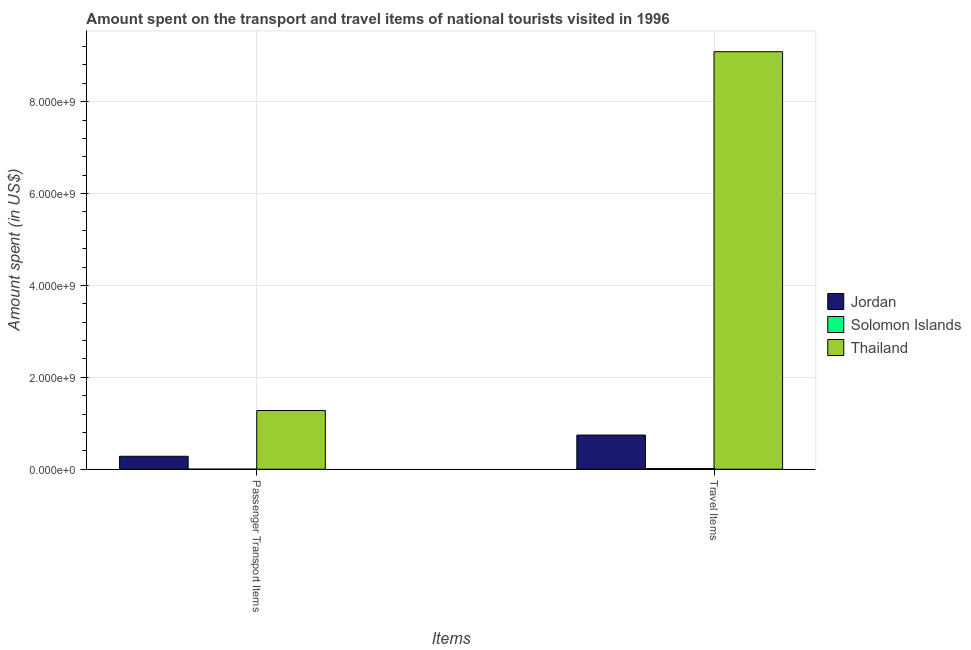How many groups of bars are there?
Your answer should be very brief. 2. Are the number of bars on each tick of the X-axis equal?
Offer a terse response. Yes. What is the label of the 2nd group of bars from the left?
Provide a short and direct response. Travel Items. What is the amount spent in travel items in Solomon Islands?
Your answer should be very brief. 1.39e+07. Across all countries, what is the maximum amount spent on passenger transport items?
Your response must be concise. 1.28e+09. Across all countries, what is the minimum amount spent in travel items?
Offer a terse response. 1.39e+07. In which country was the amount spent in travel items maximum?
Make the answer very short. Thailand. In which country was the amount spent on passenger transport items minimum?
Your answer should be compact. Solomon Islands. What is the total amount spent in travel items in the graph?
Offer a terse response. 9.85e+09. What is the difference between the amount spent on passenger transport items in Thailand and that in Solomon Islands?
Provide a short and direct response. 1.28e+09. What is the difference between the amount spent on passenger transport items in Jordan and the amount spent in travel items in Solomon Islands?
Your answer should be very brief. 2.68e+08. What is the average amount spent in travel items per country?
Provide a short and direct response. 3.28e+09. What is the difference between the amount spent on passenger transport items and amount spent in travel items in Thailand?
Your answer should be compact. -7.81e+09. In how many countries, is the amount spent in travel items greater than 1600000000 US$?
Offer a very short reply. 1. What is the ratio of the amount spent on passenger transport items in Solomon Islands to that in Thailand?
Offer a terse response. 0. Is the amount spent in travel items in Solomon Islands less than that in Thailand?
Offer a very short reply. Yes. In how many countries, is the amount spent in travel items greater than the average amount spent in travel items taken over all countries?
Provide a succinct answer. 1. What does the 1st bar from the left in Passenger Transport Items represents?
Provide a succinct answer. Jordan. What does the 2nd bar from the right in Travel Items represents?
Offer a very short reply. Solomon Islands. Are all the bars in the graph horizontal?
Ensure brevity in your answer.  No. How many countries are there in the graph?
Offer a terse response. 3. What is the difference between two consecutive major ticks on the Y-axis?
Provide a short and direct response. 2.00e+09. Are the values on the major ticks of Y-axis written in scientific E-notation?
Your response must be concise. Yes. Does the graph contain grids?
Ensure brevity in your answer.  Yes. How many legend labels are there?
Your answer should be compact. 3. What is the title of the graph?
Offer a very short reply. Amount spent on the transport and travel items of national tourists visited in 1996. Does "Middle income" appear as one of the legend labels in the graph?
Offer a terse response. No. What is the label or title of the X-axis?
Offer a very short reply. Items. What is the label or title of the Y-axis?
Provide a short and direct response. Amount spent (in US$). What is the Amount spent (in US$) in Jordan in Passenger Transport Items?
Provide a short and direct response. 2.82e+08. What is the Amount spent (in US$) in Solomon Islands in Passenger Transport Items?
Offer a terse response. 2.10e+06. What is the Amount spent (in US$) of Thailand in Passenger Transport Items?
Your response must be concise. 1.28e+09. What is the Amount spent (in US$) of Jordan in Travel Items?
Provide a succinct answer. 7.44e+08. What is the Amount spent (in US$) of Solomon Islands in Travel Items?
Provide a short and direct response. 1.39e+07. What is the Amount spent (in US$) of Thailand in Travel Items?
Provide a succinct answer. 9.09e+09. Across all Items, what is the maximum Amount spent (in US$) in Jordan?
Ensure brevity in your answer.  7.44e+08. Across all Items, what is the maximum Amount spent (in US$) in Solomon Islands?
Keep it short and to the point. 1.39e+07. Across all Items, what is the maximum Amount spent (in US$) of Thailand?
Keep it short and to the point. 9.09e+09. Across all Items, what is the minimum Amount spent (in US$) of Jordan?
Your answer should be compact. 2.82e+08. Across all Items, what is the minimum Amount spent (in US$) in Solomon Islands?
Give a very brief answer. 2.10e+06. Across all Items, what is the minimum Amount spent (in US$) in Thailand?
Provide a succinct answer. 1.28e+09. What is the total Amount spent (in US$) of Jordan in the graph?
Offer a terse response. 1.03e+09. What is the total Amount spent (in US$) in Solomon Islands in the graph?
Give a very brief answer. 1.60e+07. What is the total Amount spent (in US$) of Thailand in the graph?
Keep it short and to the point. 1.04e+1. What is the difference between the Amount spent (in US$) of Jordan in Passenger Transport Items and that in Travel Items?
Keep it short and to the point. -4.62e+08. What is the difference between the Amount spent (in US$) in Solomon Islands in Passenger Transport Items and that in Travel Items?
Provide a succinct answer. -1.18e+07. What is the difference between the Amount spent (in US$) in Thailand in Passenger Transport Items and that in Travel Items?
Offer a very short reply. -7.81e+09. What is the difference between the Amount spent (in US$) in Jordan in Passenger Transport Items and the Amount spent (in US$) in Solomon Islands in Travel Items?
Your answer should be very brief. 2.68e+08. What is the difference between the Amount spent (in US$) of Jordan in Passenger Transport Items and the Amount spent (in US$) of Thailand in Travel Items?
Make the answer very short. -8.81e+09. What is the difference between the Amount spent (in US$) of Solomon Islands in Passenger Transport Items and the Amount spent (in US$) of Thailand in Travel Items?
Your answer should be very brief. -9.09e+09. What is the average Amount spent (in US$) in Jordan per Items?
Provide a succinct answer. 5.13e+08. What is the average Amount spent (in US$) of Solomon Islands per Items?
Ensure brevity in your answer.  8.00e+06. What is the average Amount spent (in US$) of Thailand per Items?
Give a very brief answer. 5.18e+09. What is the difference between the Amount spent (in US$) in Jordan and Amount spent (in US$) in Solomon Islands in Passenger Transport Items?
Ensure brevity in your answer.  2.80e+08. What is the difference between the Amount spent (in US$) in Jordan and Amount spent (in US$) in Thailand in Passenger Transport Items?
Provide a short and direct response. -9.96e+08. What is the difference between the Amount spent (in US$) of Solomon Islands and Amount spent (in US$) of Thailand in Passenger Transport Items?
Your response must be concise. -1.28e+09. What is the difference between the Amount spent (in US$) of Jordan and Amount spent (in US$) of Solomon Islands in Travel Items?
Your answer should be compact. 7.30e+08. What is the difference between the Amount spent (in US$) in Jordan and Amount spent (in US$) in Thailand in Travel Items?
Provide a short and direct response. -8.34e+09. What is the difference between the Amount spent (in US$) of Solomon Islands and Amount spent (in US$) of Thailand in Travel Items?
Your response must be concise. -9.08e+09. What is the ratio of the Amount spent (in US$) of Jordan in Passenger Transport Items to that in Travel Items?
Offer a terse response. 0.38. What is the ratio of the Amount spent (in US$) in Solomon Islands in Passenger Transport Items to that in Travel Items?
Your answer should be very brief. 0.15. What is the ratio of the Amount spent (in US$) of Thailand in Passenger Transport Items to that in Travel Items?
Your answer should be compact. 0.14. What is the difference between the highest and the second highest Amount spent (in US$) of Jordan?
Provide a succinct answer. 4.62e+08. What is the difference between the highest and the second highest Amount spent (in US$) in Solomon Islands?
Provide a succinct answer. 1.18e+07. What is the difference between the highest and the second highest Amount spent (in US$) in Thailand?
Offer a terse response. 7.81e+09. What is the difference between the highest and the lowest Amount spent (in US$) in Jordan?
Provide a succinct answer. 4.62e+08. What is the difference between the highest and the lowest Amount spent (in US$) of Solomon Islands?
Your answer should be very brief. 1.18e+07. What is the difference between the highest and the lowest Amount spent (in US$) of Thailand?
Give a very brief answer. 7.81e+09. 